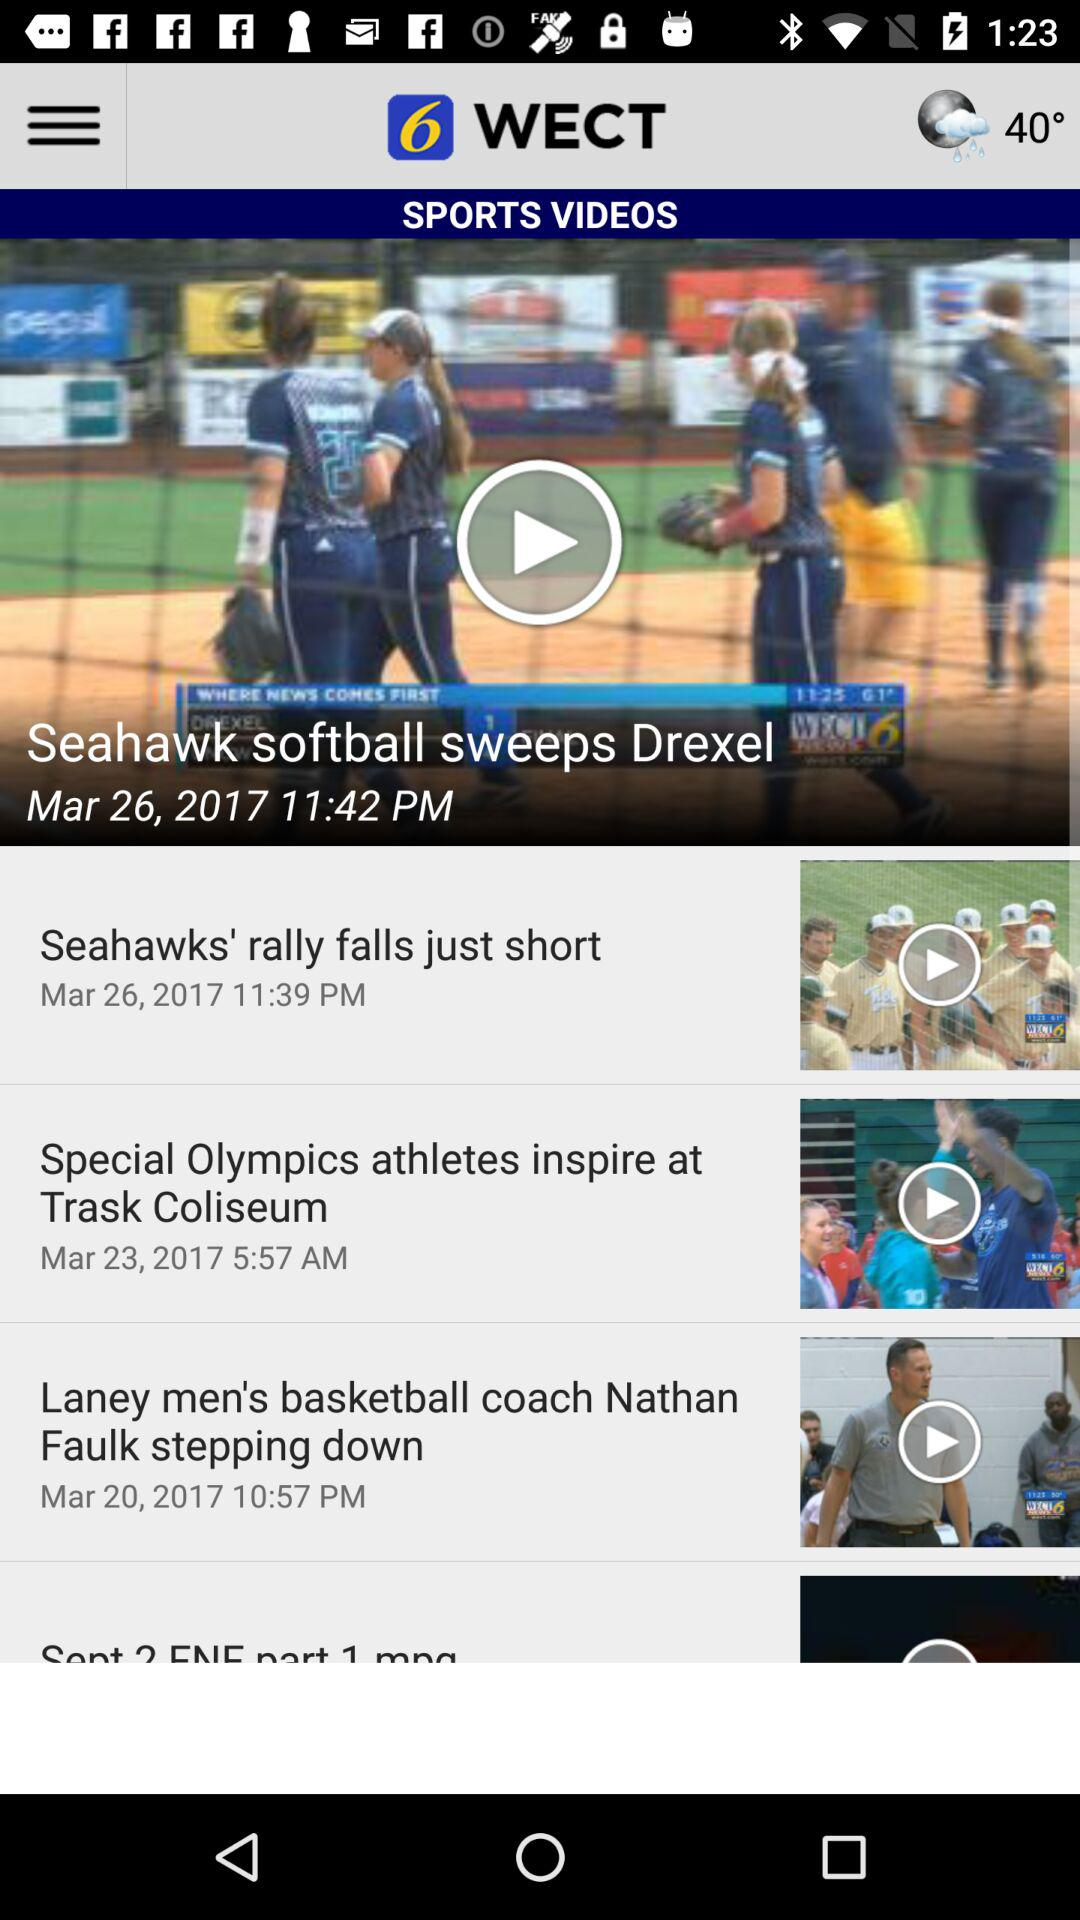Which option is selected?
When the provided information is insufficient, respond with <no answer>. <no answer> 